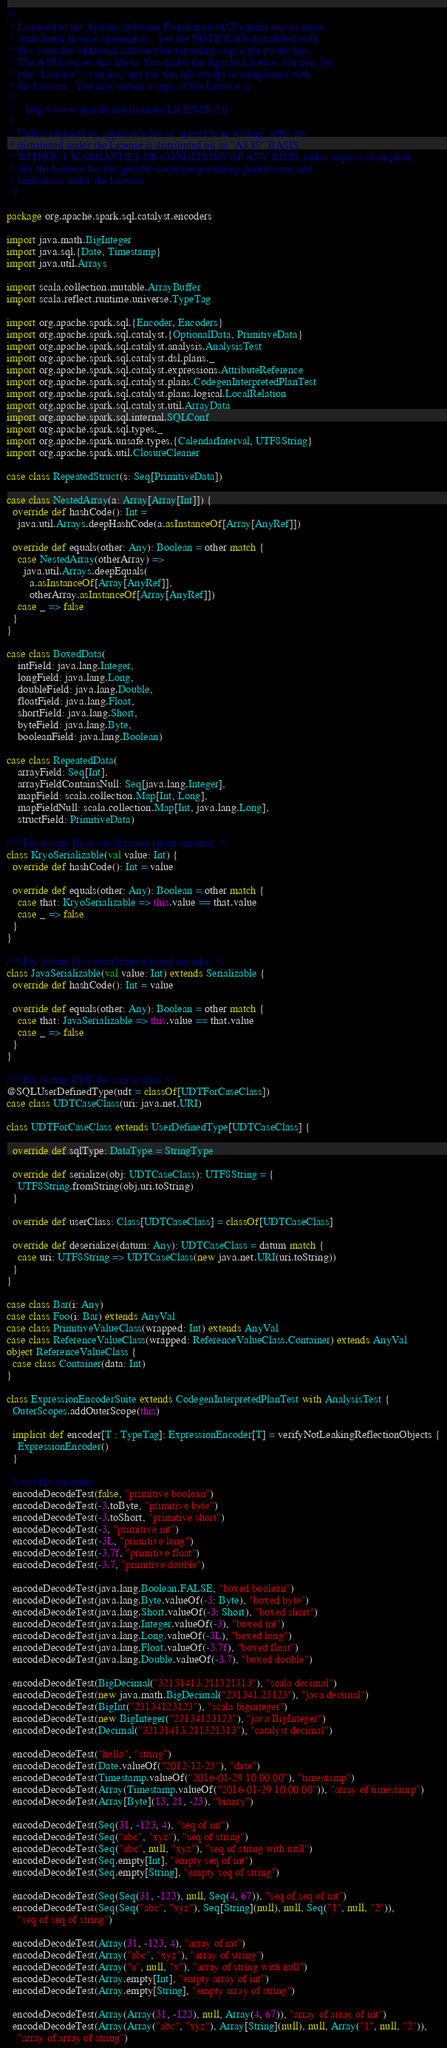Convert code to text. <code><loc_0><loc_0><loc_500><loc_500><_Scala_>/*
 * Licensed to the Apache Software Foundation (ASF) under one or more
 * contributor license agreements.  See the NOTICE file distributed with
 * this work for additional information regarding copyright ownership.
 * The ASF licenses this file to You under the Apache License, Version 2.0
 * (the "License"); you may not use this file except in compliance with
 * the License.  You may obtain a copy of the License at
 *
 *    http://www.apache.org/licenses/LICENSE-2.0
 *
 * Unless required by applicable law or agreed to in writing, software
 * distributed under the License is distributed on an "AS IS" BASIS,
 * WITHOUT WARRANTIES OR CONDITIONS OF ANY KIND, either express or implied.
 * See the License for the specific language governing permissions and
 * limitations under the License.
 */

package org.apache.spark.sql.catalyst.encoders

import java.math.BigInteger
import java.sql.{Date, Timestamp}
import java.util.Arrays

import scala.collection.mutable.ArrayBuffer
import scala.reflect.runtime.universe.TypeTag

import org.apache.spark.sql.{Encoder, Encoders}
import org.apache.spark.sql.catalyst.{OptionalData, PrimitiveData}
import org.apache.spark.sql.catalyst.analysis.AnalysisTest
import org.apache.spark.sql.catalyst.dsl.plans._
import org.apache.spark.sql.catalyst.expressions.AttributeReference
import org.apache.spark.sql.catalyst.plans.CodegenInterpretedPlanTest
import org.apache.spark.sql.catalyst.plans.logical.LocalRelation
import org.apache.spark.sql.catalyst.util.ArrayData
import org.apache.spark.sql.internal.SQLConf
import org.apache.spark.sql.types._
import org.apache.spark.unsafe.types.{CalendarInterval, UTF8String}
import org.apache.spark.util.ClosureCleaner

case class RepeatedStruct(s: Seq[PrimitiveData])

case class NestedArray(a: Array[Array[Int]]) {
  override def hashCode(): Int =
    java.util.Arrays.deepHashCode(a.asInstanceOf[Array[AnyRef]])

  override def equals(other: Any): Boolean = other match {
    case NestedArray(otherArray) =>
      java.util.Arrays.deepEquals(
        a.asInstanceOf[Array[AnyRef]],
        otherArray.asInstanceOf[Array[AnyRef]])
    case _ => false
  }
}

case class BoxedData(
    intField: java.lang.Integer,
    longField: java.lang.Long,
    doubleField: java.lang.Double,
    floatField: java.lang.Float,
    shortField: java.lang.Short,
    byteField: java.lang.Byte,
    booleanField: java.lang.Boolean)

case class RepeatedData(
    arrayField: Seq[Int],
    arrayFieldContainsNull: Seq[java.lang.Integer],
    mapField: scala.collection.Map[Int, Long],
    mapFieldNull: scala.collection.Map[Int, java.lang.Long],
    structField: PrimitiveData)

/** For testing Kryo serialization based encoder. */
class KryoSerializable(val value: Int) {
  override def hashCode(): Int = value

  override def equals(other: Any): Boolean = other match {
    case that: KryoSerializable => this.value == that.value
    case _ => false
  }
}

/** For testing Java serialization based encoder. */
class JavaSerializable(val value: Int) extends Serializable {
  override def hashCode(): Int = value

  override def equals(other: Any): Boolean = other match {
    case that: JavaSerializable => this.value == that.value
    case _ => false
  }
}

/** For testing UDT for a case class */
@SQLUserDefinedType(udt = classOf[UDTForCaseClass])
case class UDTCaseClass(uri: java.net.URI)

class UDTForCaseClass extends UserDefinedType[UDTCaseClass] {

  override def sqlType: DataType = StringType

  override def serialize(obj: UDTCaseClass): UTF8String = {
    UTF8String.fromString(obj.uri.toString)
  }

  override def userClass: Class[UDTCaseClass] = classOf[UDTCaseClass]

  override def deserialize(datum: Any): UDTCaseClass = datum match {
    case uri: UTF8String => UDTCaseClass(new java.net.URI(uri.toString))
  }
}

case class Bar(i: Any)
case class Foo(i: Bar) extends AnyVal
case class PrimitiveValueClass(wrapped: Int) extends AnyVal
case class ReferenceValueClass(wrapped: ReferenceValueClass.Container) extends AnyVal
object ReferenceValueClass {
  case class Container(data: Int)
}

class ExpressionEncoderSuite extends CodegenInterpretedPlanTest with AnalysisTest {
  OuterScopes.addOuterScope(this)

  implicit def encoder[T : TypeTag]: ExpressionEncoder[T] = verifyNotLeakingReflectionObjects {
    ExpressionEncoder()
  }

  // test flat encoders
  encodeDecodeTest(false, "primitive boolean")
  encodeDecodeTest(-3.toByte, "primitive byte")
  encodeDecodeTest(-3.toShort, "primitive short")
  encodeDecodeTest(-3, "primitive int")
  encodeDecodeTest(-3L, "primitive long")
  encodeDecodeTest(-3.7f, "primitive float")
  encodeDecodeTest(-3.7, "primitive double")

  encodeDecodeTest(java.lang.Boolean.FALSE, "boxed boolean")
  encodeDecodeTest(java.lang.Byte.valueOf(-3: Byte), "boxed byte")
  encodeDecodeTest(java.lang.Short.valueOf(-3: Short), "boxed short")
  encodeDecodeTest(java.lang.Integer.valueOf(-3), "boxed int")
  encodeDecodeTest(java.lang.Long.valueOf(-3L), "boxed long")
  encodeDecodeTest(java.lang.Float.valueOf(-3.7f), "boxed float")
  encodeDecodeTest(java.lang.Double.valueOf(-3.7), "boxed double")

  encodeDecodeTest(BigDecimal("32131413.211321313"), "scala decimal")
  encodeDecodeTest(new java.math.BigDecimal("231341.23123"), "java decimal")
  encodeDecodeTest(BigInt("23134123123"), "scala biginteger")
  encodeDecodeTest(new BigInteger("23134123123"), "java BigInteger")
  encodeDecodeTest(Decimal("32131413.211321313"), "catalyst decimal")

  encodeDecodeTest("hello", "string")
  encodeDecodeTest(Date.valueOf("2012-12-23"), "date")
  encodeDecodeTest(Timestamp.valueOf("2016-01-29 10:00:00"), "timestamp")
  encodeDecodeTest(Array(Timestamp.valueOf("2016-01-29 10:00:00")), "array of timestamp")
  encodeDecodeTest(Array[Byte](13, 21, -23), "binary")

  encodeDecodeTest(Seq(31, -123, 4), "seq of int")
  encodeDecodeTest(Seq("abc", "xyz"), "seq of string")
  encodeDecodeTest(Seq("abc", null, "xyz"), "seq of string with null")
  encodeDecodeTest(Seq.empty[Int], "empty seq of int")
  encodeDecodeTest(Seq.empty[String], "empty seq of string")

  encodeDecodeTest(Seq(Seq(31, -123), null, Seq(4, 67)), "seq of seq of int")
  encodeDecodeTest(Seq(Seq("abc", "xyz"), Seq[String](null), null, Seq("1", null, "2")),
    "seq of seq of string")

  encodeDecodeTest(Array(31, -123, 4), "array of int")
  encodeDecodeTest(Array("abc", "xyz"), "array of string")
  encodeDecodeTest(Array("a", null, "x"), "array of string with null")
  encodeDecodeTest(Array.empty[Int], "empty array of int")
  encodeDecodeTest(Array.empty[String], "empty array of string")

  encodeDecodeTest(Array(Array(31, -123), null, Array(4, 67)), "array of array of int")
  encodeDecodeTest(Array(Array("abc", "xyz"), Array[String](null), null, Array("1", null, "2")),
    "array of array of string")
</code> 